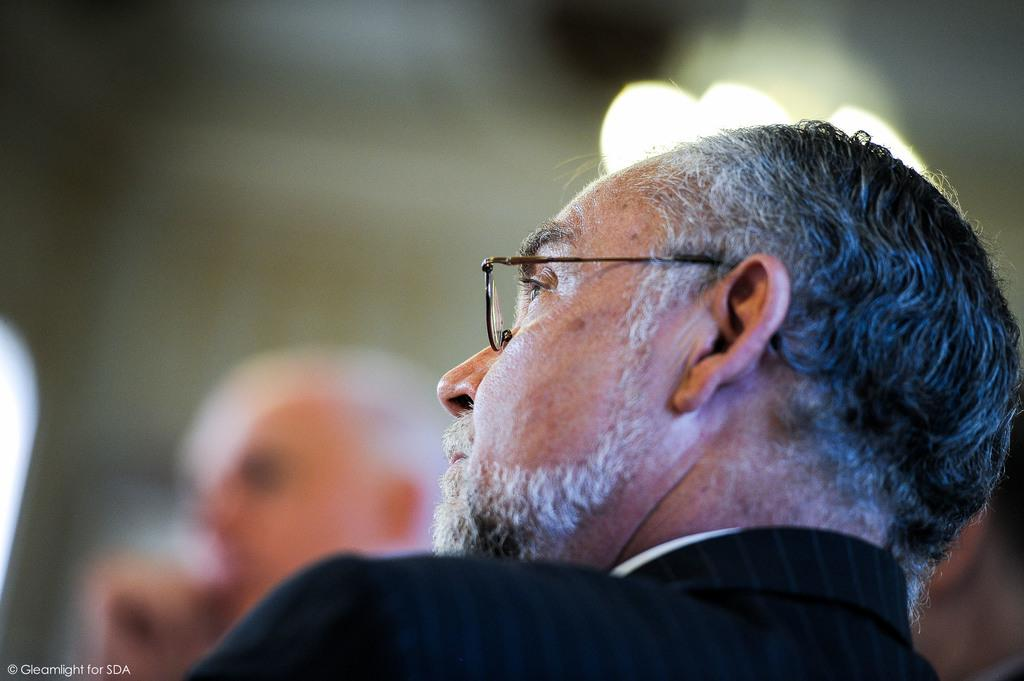Who is present in the image? There is a man in the image. What can be found in the bottom left corner of the image? There is text in the bottom left corner of the image. How would you describe the background of the image? The background of the image is blurred. What is the queen's interest in the image? There is no queen present in the image, so it is not possible to determine her interest. 